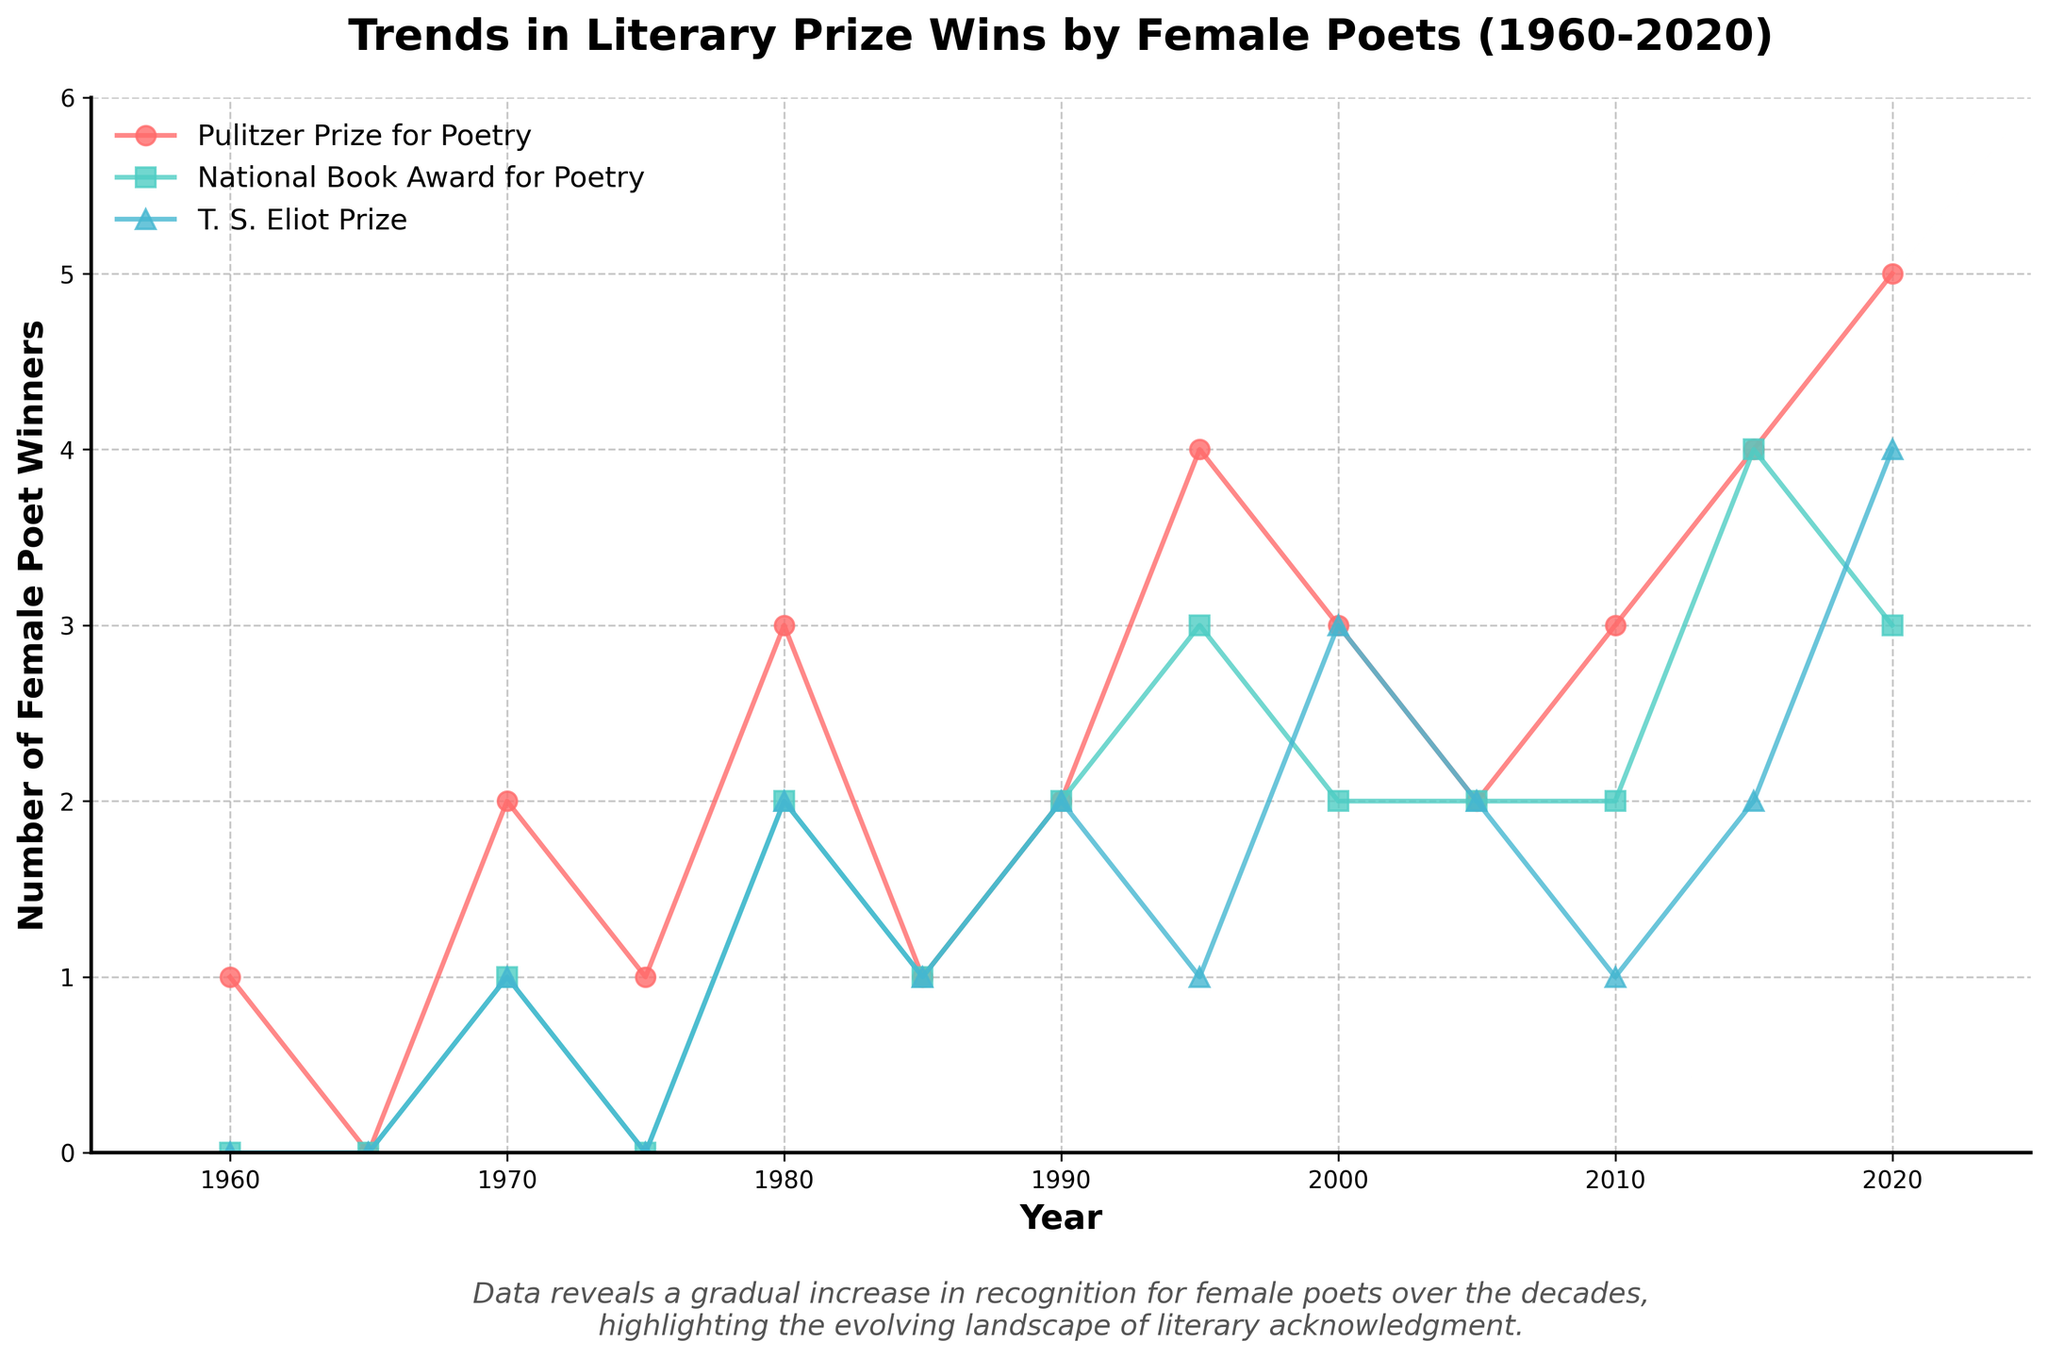What is the title of the figure? The title is located at the top of the figure and typically describes the main focus of the plotted data.
Answer: Trends in Literary Prize Wins by Female Poets (1960-2020) How many prize categories are shown in the figure? By counting the distinct markers or lines shown in the legend, we can determine the number of prize categories.
Answer: Three Which prize category saw the highest number of female poet wins in 2020? By examining the endpoints of the lines for the year 2020, one can compare the values to determine the highest number. The category with the highest endpoint value represents the highest number of wins.
Answer: Pulitzer Prize for Poetry In which decade did the National Book Award for Poetry first have any female poet winners? By tracing the line for the National Book Award for Poetry back in time, we look for the first non-zero data point, which falls in a specific decade.
Answer: 1970s How many total wins did female poets achieve in the Pulitzer Prize for Poetry from 1995 to 2020? Sum the values at each 5-year interval starting from 1995 up to and including 2020 for the Pulitzer Prize for Poetry.
Answer: 21 Between the Pulitzer Prize for Poetry and the T. S. Eliot Prize, which category had more winners in the year 2000? Compare the data points for both prize categories at the year 2000.
Answer: T. S. Eliot Prize What is the general trend in the number of female poet wins for the T. S. Eliot Prize from 1960 to 2020? Analyze the plotted line for the T. S. Eliot Prize and describe whether the number of wins increases, decreases, or remains constant over time.
Answer: Increasing How often were there no female poet winners in the Pulitzer Prize for Poetry from 1960 to 2020? Identify the data points that are zero in the Pulitzer Prize for Poetry line and count the occurrences.
Answer: Once During which time period did female poet wins in the National Book Award for Poetry see the most significant increase? Identify the time interval where the slope of the National Book Award for Poetry line is steepest, indicating the largest numeric change.
Answer: 1990 to 1995 Which prize category shows the most variability in the number of female poet winners over the decades? By comparing the fluctuations in the lines, determine which prize category has the highest variation in the number of wins.
Answer: T. S. Eliot Prize 